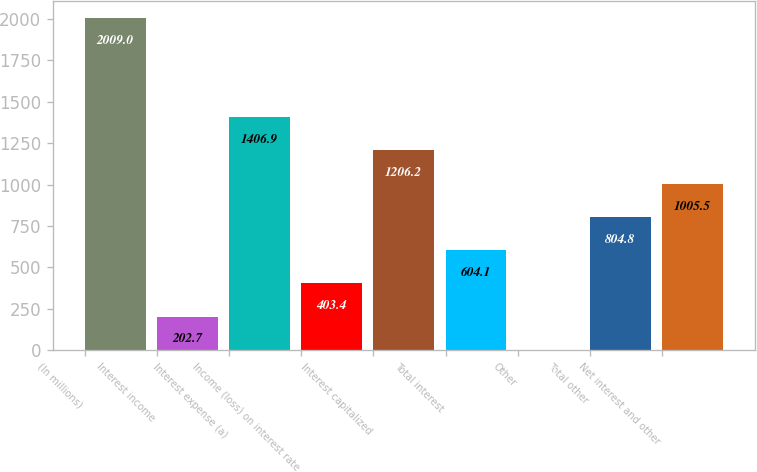Convert chart to OTSL. <chart><loc_0><loc_0><loc_500><loc_500><bar_chart><fcel>(In millions)<fcel>Interest income<fcel>Interest expense (a)<fcel>Income (loss) on interest rate<fcel>Interest capitalized<fcel>Total interest<fcel>Other<fcel>Total other<fcel>Net interest and other<nl><fcel>2009<fcel>202.7<fcel>1406.9<fcel>403.4<fcel>1206.2<fcel>604.1<fcel>2<fcel>804.8<fcel>1005.5<nl></chart> 